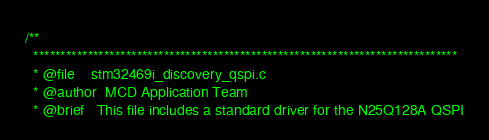Convert code to text. <code><loc_0><loc_0><loc_500><loc_500><_C_>/**
  ******************************************************************************
  * @file    stm32469i_discovery_qspi.c
  * @author  MCD Application Team
  * @brief   This file includes a standard driver for the N25Q128A QSPI</code> 